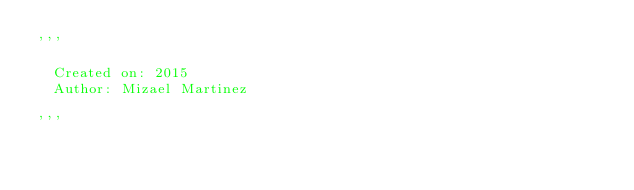<code> <loc_0><loc_0><loc_500><loc_500><_Python_>'''
  
  Created on: 2015
  Author: Mizael Martinez

'''</code> 